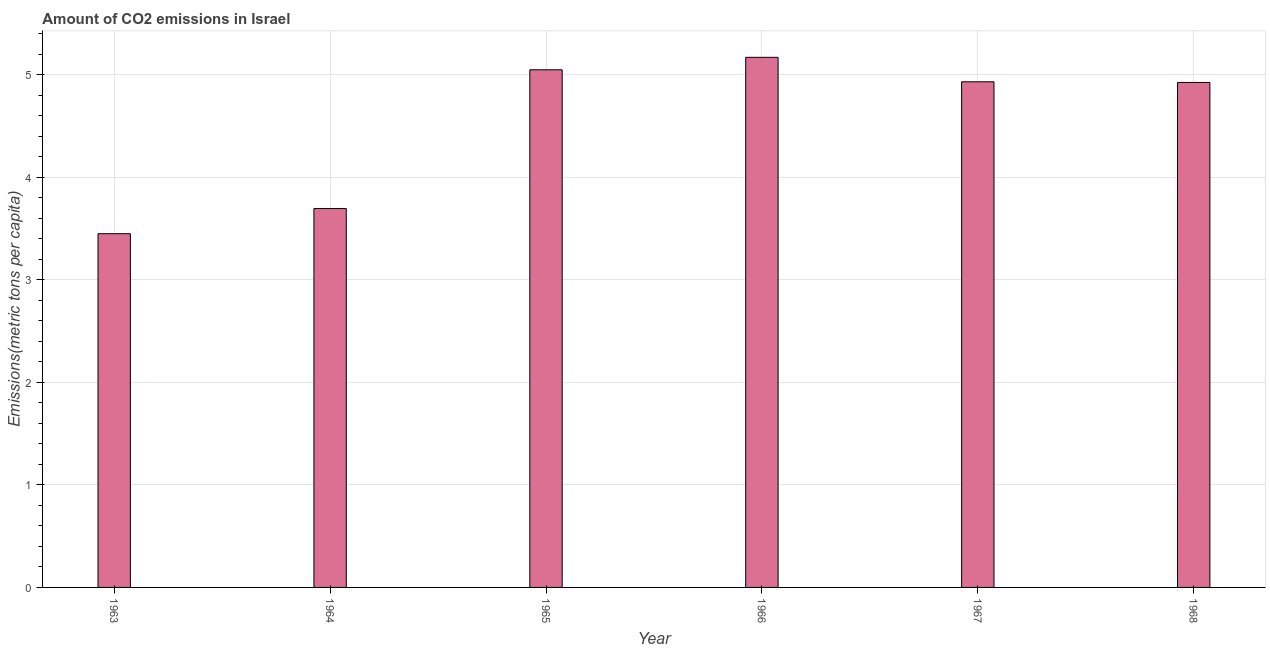What is the title of the graph?
Offer a terse response. Amount of CO2 emissions in Israel. What is the label or title of the Y-axis?
Ensure brevity in your answer.  Emissions(metric tons per capita). What is the amount of co2 emissions in 1963?
Provide a succinct answer. 3.45. Across all years, what is the maximum amount of co2 emissions?
Your response must be concise. 5.17. Across all years, what is the minimum amount of co2 emissions?
Ensure brevity in your answer.  3.45. In which year was the amount of co2 emissions maximum?
Give a very brief answer. 1966. What is the sum of the amount of co2 emissions?
Offer a very short reply. 27.23. What is the difference between the amount of co2 emissions in 1963 and 1965?
Make the answer very short. -1.6. What is the average amount of co2 emissions per year?
Keep it short and to the point. 4.54. What is the median amount of co2 emissions?
Provide a short and direct response. 4.93. Do a majority of the years between 1965 and 1966 (inclusive) have amount of co2 emissions greater than 1.4 metric tons per capita?
Give a very brief answer. Yes. What is the ratio of the amount of co2 emissions in 1965 to that in 1967?
Your response must be concise. 1.02. Is the difference between the amount of co2 emissions in 1963 and 1967 greater than the difference between any two years?
Provide a short and direct response. No. What is the difference between the highest and the second highest amount of co2 emissions?
Offer a terse response. 0.12. Is the sum of the amount of co2 emissions in 1966 and 1968 greater than the maximum amount of co2 emissions across all years?
Your answer should be compact. Yes. What is the difference between the highest and the lowest amount of co2 emissions?
Make the answer very short. 1.72. Are all the bars in the graph horizontal?
Your answer should be very brief. No. What is the difference between two consecutive major ticks on the Y-axis?
Make the answer very short. 1. What is the Emissions(metric tons per capita) of 1963?
Keep it short and to the point. 3.45. What is the Emissions(metric tons per capita) of 1964?
Your answer should be compact. 3.7. What is the Emissions(metric tons per capita) of 1965?
Offer a very short reply. 5.05. What is the Emissions(metric tons per capita) of 1966?
Provide a succinct answer. 5.17. What is the Emissions(metric tons per capita) in 1967?
Offer a terse response. 4.93. What is the Emissions(metric tons per capita) in 1968?
Ensure brevity in your answer.  4.93. What is the difference between the Emissions(metric tons per capita) in 1963 and 1964?
Ensure brevity in your answer.  -0.25. What is the difference between the Emissions(metric tons per capita) in 1963 and 1965?
Give a very brief answer. -1.6. What is the difference between the Emissions(metric tons per capita) in 1963 and 1966?
Your answer should be compact. -1.72. What is the difference between the Emissions(metric tons per capita) in 1963 and 1967?
Offer a very short reply. -1.48. What is the difference between the Emissions(metric tons per capita) in 1963 and 1968?
Your answer should be compact. -1.48. What is the difference between the Emissions(metric tons per capita) in 1964 and 1965?
Provide a short and direct response. -1.35. What is the difference between the Emissions(metric tons per capita) in 1964 and 1966?
Offer a terse response. -1.48. What is the difference between the Emissions(metric tons per capita) in 1964 and 1967?
Give a very brief answer. -1.24. What is the difference between the Emissions(metric tons per capita) in 1964 and 1968?
Your answer should be compact. -1.23. What is the difference between the Emissions(metric tons per capita) in 1965 and 1966?
Offer a terse response. -0.12. What is the difference between the Emissions(metric tons per capita) in 1965 and 1967?
Your response must be concise. 0.12. What is the difference between the Emissions(metric tons per capita) in 1965 and 1968?
Offer a terse response. 0.12. What is the difference between the Emissions(metric tons per capita) in 1966 and 1967?
Ensure brevity in your answer.  0.24. What is the difference between the Emissions(metric tons per capita) in 1966 and 1968?
Your response must be concise. 0.25. What is the difference between the Emissions(metric tons per capita) in 1967 and 1968?
Keep it short and to the point. 0.01. What is the ratio of the Emissions(metric tons per capita) in 1963 to that in 1964?
Provide a succinct answer. 0.93. What is the ratio of the Emissions(metric tons per capita) in 1963 to that in 1965?
Your answer should be compact. 0.68. What is the ratio of the Emissions(metric tons per capita) in 1963 to that in 1966?
Offer a terse response. 0.67. What is the ratio of the Emissions(metric tons per capita) in 1963 to that in 1968?
Your answer should be very brief. 0.7. What is the ratio of the Emissions(metric tons per capita) in 1964 to that in 1965?
Provide a short and direct response. 0.73. What is the ratio of the Emissions(metric tons per capita) in 1964 to that in 1966?
Offer a terse response. 0.71. What is the ratio of the Emissions(metric tons per capita) in 1964 to that in 1967?
Offer a terse response. 0.75. What is the ratio of the Emissions(metric tons per capita) in 1964 to that in 1968?
Provide a succinct answer. 0.75. What is the ratio of the Emissions(metric tons per capita) in 1965 to that in 1966?
Give a very brief answer. 0.98. What is the ratio of the Emissions(metric tons per capita) in 1965 to that in 1968?
Give a very brief answer. 1.02. What is the ratio of the Emissions(metric tons per capita) in 1966 to that in 1967?
Offer a terse response. 1.05. 